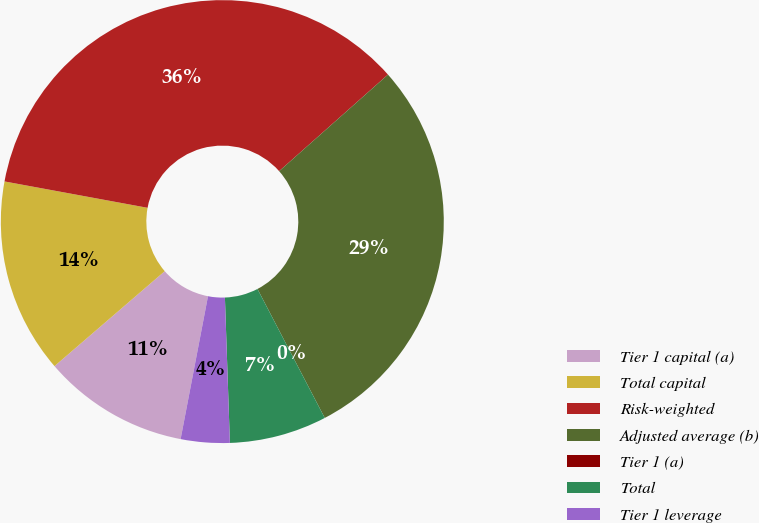<chart> <loc_0><loc_0><loc_500><loc_500><pie_chart><fcel>Tier 1 capital (a)<fcel>Total capital<fcel>Risk-weighted<fcel>Adjusted average (b)<fcel>Tier 1 (a)<fcel>Total<fcel>Tier 1 leverage<nl><fcel>10.67%<fcel>14.22%<fcel>35.55%<fcel>28.9%<fcel>0.0%<fcel>7.11%<fcel>3.56%<nl></chart> 